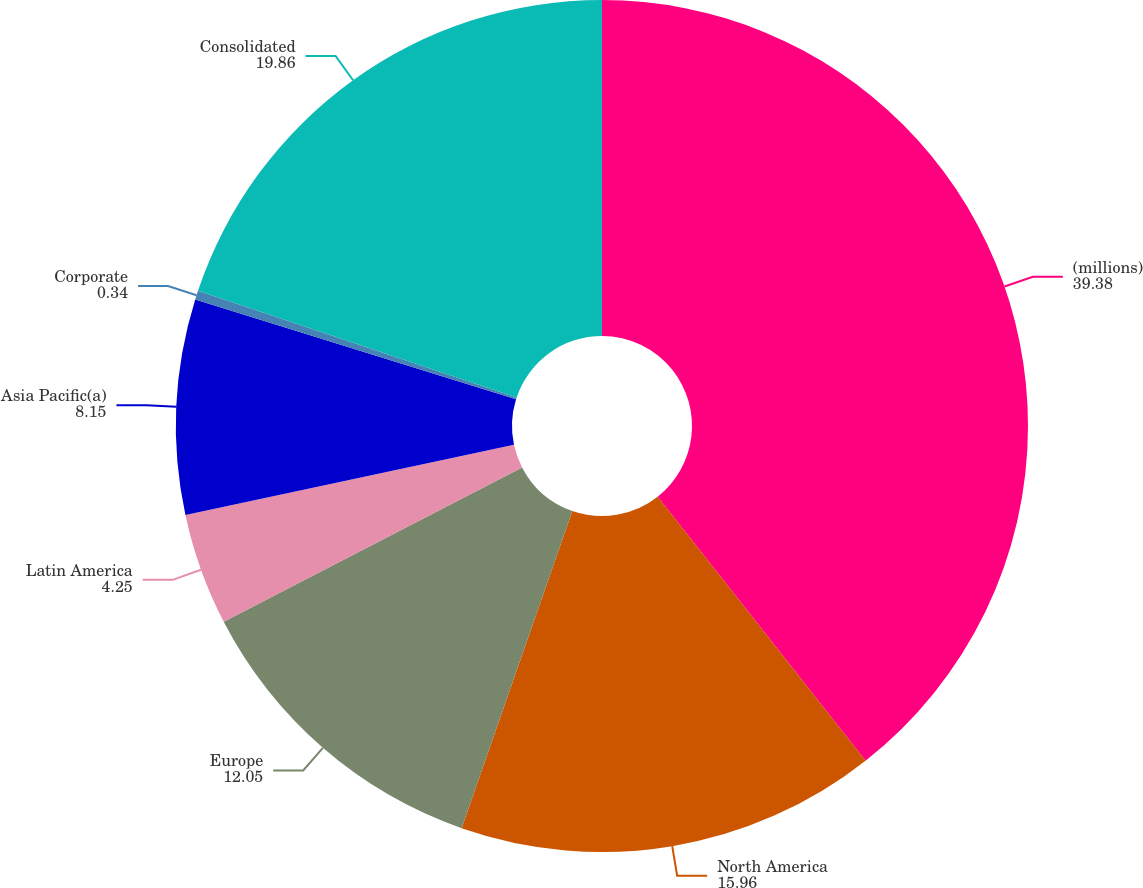Convert chart to OTSL. <chart><loc_0><loc_0><loc_500><loc_500><pie_chart><fcel>(millions)<fcel>North America<fcel>Europe<fcel>Latin America<fcel>Asia Pacific(a)<fcel>Corporate<fcel>Consolidated<nl><fcel>39.38%<fcel>15.96%<fcel>12.05%<fcel>4.25%<fcel>8.15%<fcel>0.34%<fcel>19.86%<nl></chart> 